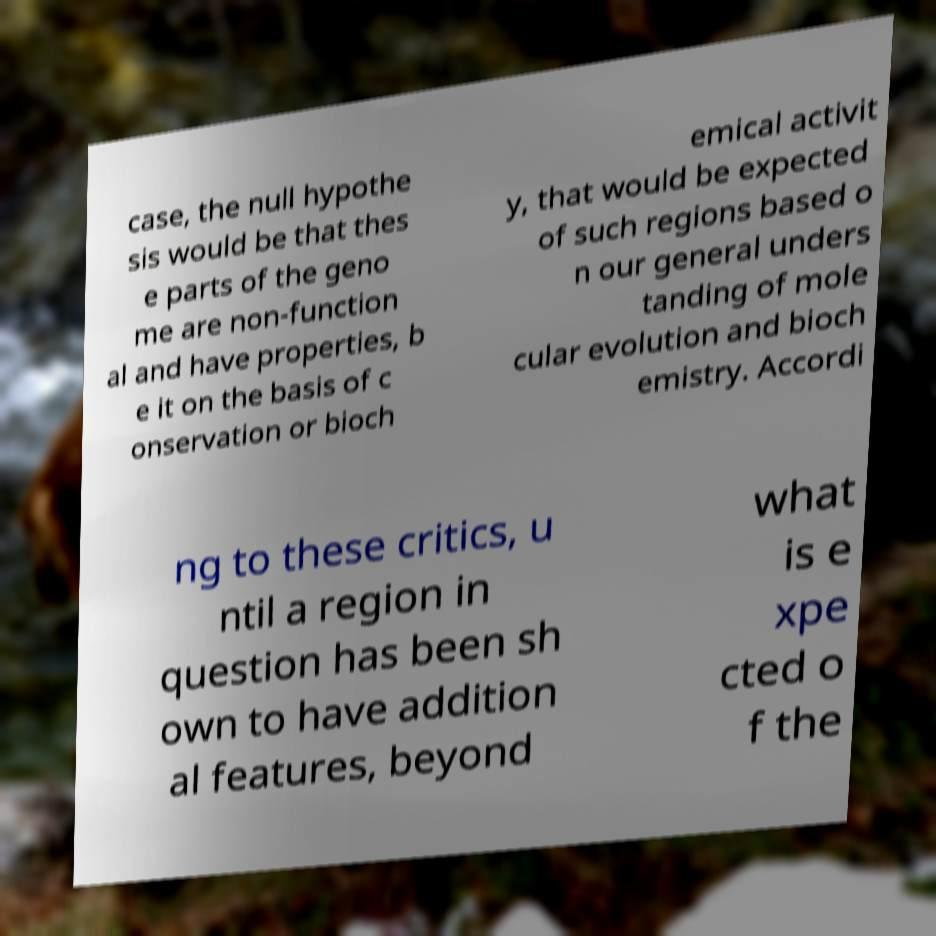There's text embedded in this image that I need extracted. Can you transcribe it verbatim? case, the null hypothe sis would be that thes e parts of the geno me are non-function al and have properties, b e it on the basis of c onservation or bioch emical activit y, that would be expected of such regions based o n our general unders tanding of mole cular evolution and bioch emistry. Accordi ng to these critics, u ntil a region in question has been sh own to have addition al features, beyond what is e xpe cted o f the 